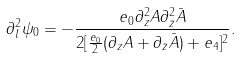<formula> <loc_0><loc_0><loc_500><loc_500>\partial _ { l } ^ { 2 } \psi _ { 0 } = - \frac { e _ { 0 } \partial _ { z } ^ { 2 } A \partial _ { \bar { z } } ^ { 2 } \bar { A } } { 2 [ \frac { e _ { 0 } } { 2 } ( \partial _ { z } A + \partial _ { \bar { z } } \bar { A } ) + e _ { 4 } ] ^ { 2 } } .</formula> 